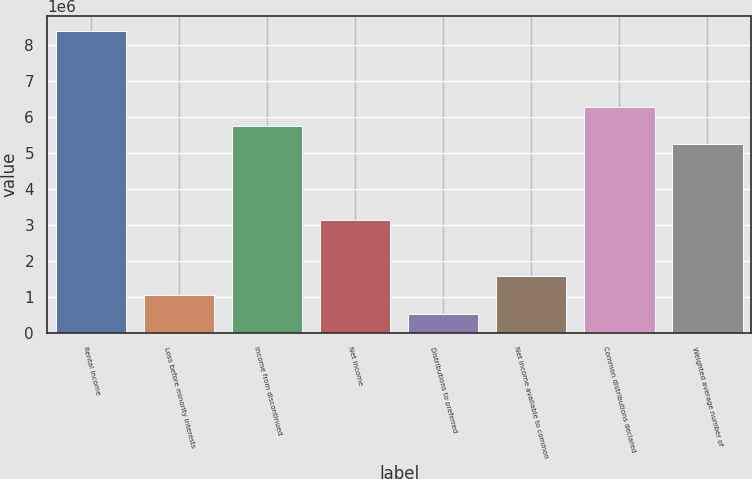Convert chart. <chart><loc_0><loc_0><loc_500><loc_500><bar_chart><fcel>Rental income<fcel>Loss before minority interests<fcel>Income from discontinued<fcel>Net income<fcel>Distributions to preferred<fcel>Net income available to common<fcel>Common distributions declared<fcel>Weighted average number of<nl><fcel>8.38927e+06<fcel>1.04866e+06<fcel>5.76763e+06<fcel>3.14598e+06<fcel>524330<fcel>1.57299e+06<fcel>6.29196e+06<fcel>5.2433e+06<nl></chart> 